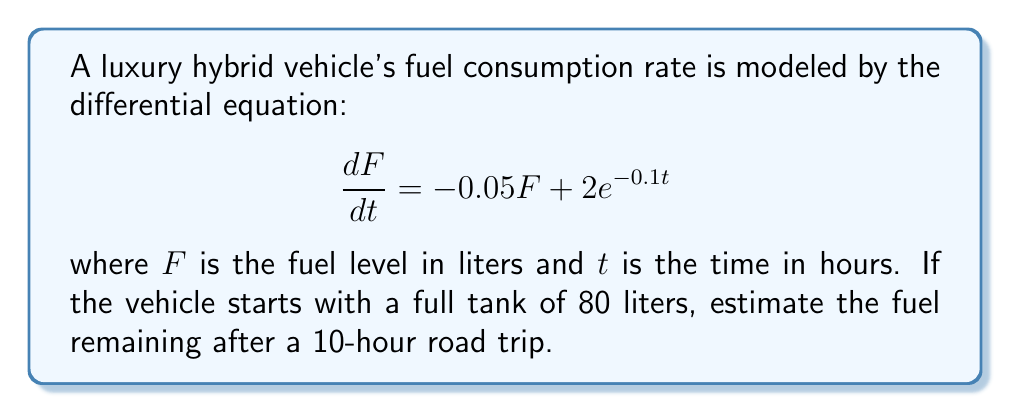Solve this math problem. To solve this first-order linear differential equation, we'll use the integrating factor method:

1) The equation is in the form $\frac{dF}{dt} + 0.05F = 2e^{-0.1t}$

2) The integrating factor is $\mu(t) = e^{\int 0.05 dt} = e^{0.05t}$

3) Multiply both sides by $\mu(t)$:

   $e^{0.05t}\frac{dF}{dt} + 0.05Fe^{0.05t} = 2e^{-0.1t}e^{0.05t}$

4) The left side is now the derivative of $Fe^{0.05t}$:

   $\frac{d}{dt}(Fe^{0.05t}) = 2e^{-0.05t}$

5) Integrate both sides:

   $Fe^{0.05t} = -40e^{-0.05t} + C$

6) Solve for $F$:

   $F = -40e^{-0.1t} + Ce^{-0.05t}$

7) Use the initial condition $F(0) = 80$ to find $C$:

   $80 = -40 + C$
   $C = 120$

8) The general solution is:

   $F = -40e^{-0.1t} + 120e^{-0.05t}$

9) To find the fuel level after 10 hours, substitute $t = 10$:

   $F(10) = -40e^{-0.1(10)} + 120e^{-0.05(10)}$
   $= -40(0.3679) + 120(0.6065)$
   $= -14.716 + 72.78$
   $= 58.064$
Answer: After a 10-hour road trip, approximately 58.06 liters of fuel will remain in the luxury hybrid vehicle's tank. 